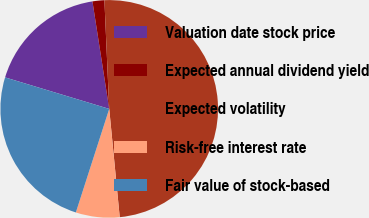<chart> <loc_0><loc_0><loc_500><loc_500><pie_chart><fcel>Valuation date stock price<fcel>Expected annual dividend yield<fcel>Expected volatility<fcel>Risk-free interest rate<fcel>Fair value of stock-based<nl><fcel>17.86%<fcel>1.76%<fcel>49.16%<fcel>6.5%<fcel>24.71%<nl></chart> 